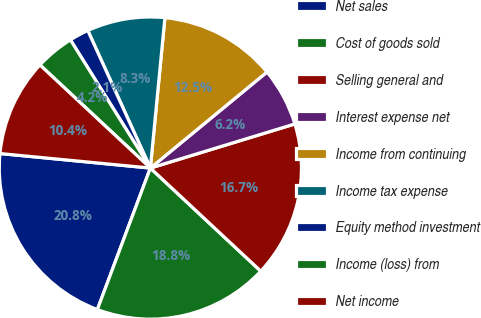Convert chart. <chart><loc_0><loc_0><loc_500><loc_500><pie_chart><fcel>Net sales<fcel>Cost of goods sold<fcel>Selling general and<fcel>Interest expense net<fcel>Income from continuing<fcel>Income tax expense<fcel>Equity method investment<fcel>Income (loss) from<fcel>Net income<nl><fcel>20.83%<fcel>18.75%<fcel>16.67%<fcel>6.25%<fcel>12.5%<fcel>8.33%<fcel>2.08%<fcel>4.17%<fcel>10.42%<nl></chart> 